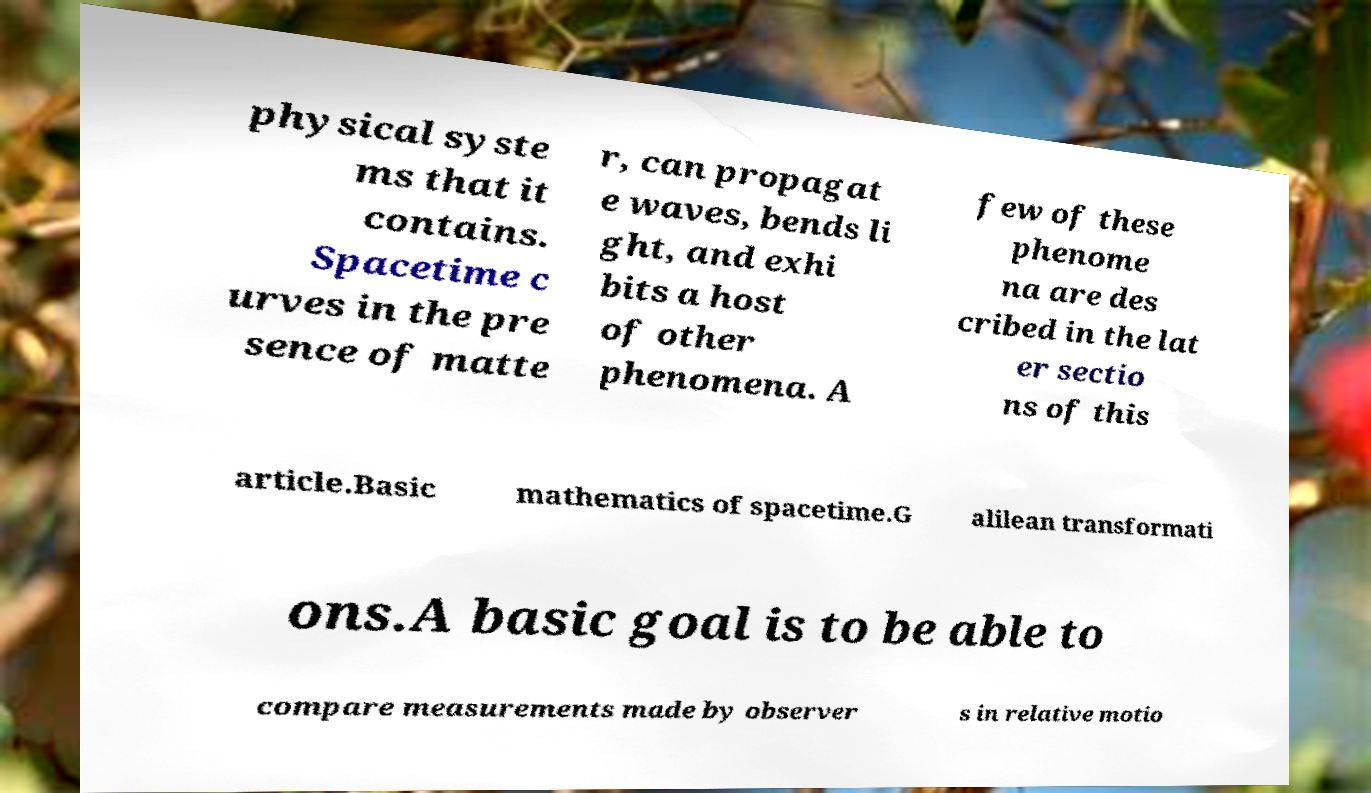Could you assist in decoding the text presented in this image and type it out clearly? physical syste ms that it contains. Spacetime c urves in the pre sence of matte r, can propagat e waves, bends li ght, and exhi bits a host of other phenomena. A few of these phenome na are des cribed in the lat er sectio ns of this article.Basic mathematics of spacetime.G alilean transformati ons.A basic goal is to be able to compare measurements made by observer s in relative motio 